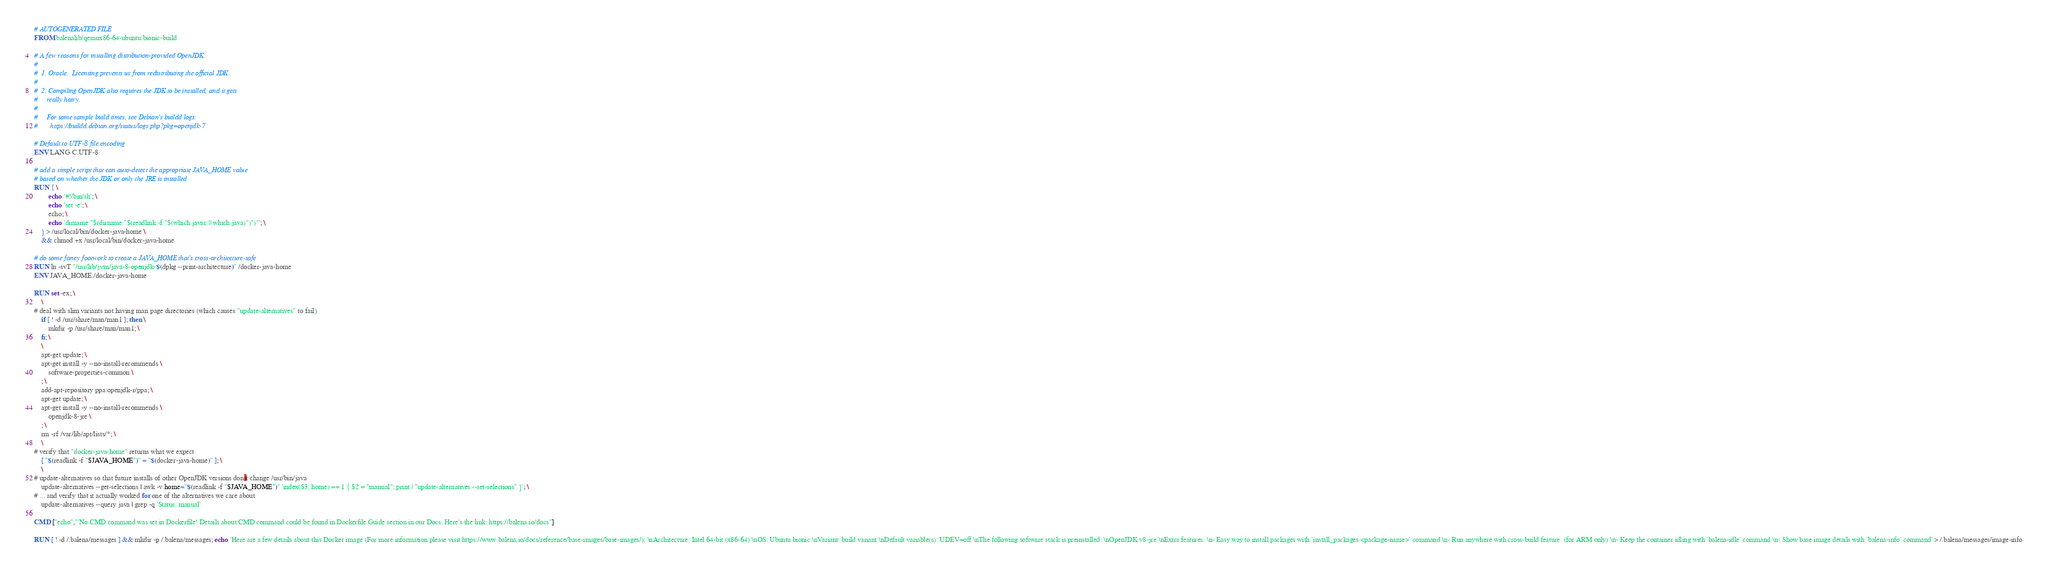Convert code to text. <code><loc_0><loc_0><loc_500><loc_500><_Dockerfile_># AUTOGENERATED FILE
FROM balenalib/qemux86-64-ubuntu:bionic-build

# A few reasons for installing distribution-provided OpenJDK:
#
#  1. Oracle.  Licensing prevents us from redistributing the official JDK.
#
#  2. Compiling OpenJDK also requires the JDK to be installed, and it gets
#     really hairy.
#
#     For some sample build times, see Debian's buildd logs:
#       https://buildd.debian.org/status/logs.php?pkg=openjdk-7

# Default to UTF-8 file.encoding
ENV LANG C.UTF-8

# add a simple script that can auto-detect the appropriate JAVA_HOME value
# based on whether the JDK or only the JRE is installed
RUN { \
		echo '#!/bin/sh'; \
		echo 'set -e'; \
		echo; \
		echo 'dirname "$(dirname "$(readlink -f "$(which javac || which java)")")"'; \
	} > /usr/local/bin/docker-java-home \
	&& chmod +x /usr/local/bin/docker-java-home

# do some fancy footwork to create a JAVA_HOME that's cross-architecture-safe
RUN ln -svT "/usr/lib/jvm/java-8-openjdk-$(dpkg --print-architecture)" /docker-java-home
ENV JAVA_HOME /docker-java-home

RUN set -ex; \
	\
# deal with slim variants not having man page directories (which causes "update-alternatives" to fail)
	if [ ! -d /usr/share/man/man1 ]; then \
		mkdir -p /usr/share/man/man1; \
	fi; \
	\
	apt-get update; \
	apt-get install -y --no-install-recommends \
		software-properties-common \
	; \
	add-apt-repository ppa:openjdk-r/ppa; \
	apt-get update; \
	apt-get install -y --no-install-recommends \
		openjdk-8-jre \
	; \
	rm -rf /var/lib/apt/lists/*; \
	\
# verify that "docker-java-home" returns what we expect
	[ "$(readlink -f "$JAVA_HOME")" = "$(docker-java-home)" ]; \
	\
# update-alternatives so that future installs of other OpenJDK versions don't change /usr/bin/java
	update-alternatives --get-selections | awk -v home="$(readlink -f "$JAVA_HOME")" 'index($3, home) == 1 { $2 = "manual"; print | "update-alternatives --set-selections" }'; \
# ... and verify that it actually worked for one of the alternatives we care about
	update-alternatives --query java | grep -q 'Status: manual'

CMD ["echo","'No CMD command was set in Dockerfile! Details about CMD command could be found in Dockerfile Guide section in our Docs. Here's the link: https://balena.io/docs"]

RUN [ ! -d /.balena/messages ] && mkdir -p /.balena/messages; echo 'Here are a few details about this Docker image (For more information please visit https://www.balena.io/docs/reference/base-images/base-images/): \nArchitecture: Intel 64-bit (x86-64) \nOS: Ubuntu bionic \nVariant: build variant \nDefault variable(s): UDEV=off \nThe following software stack is preinstalled: \nOpenJDK v8-jre \nExtra features: \n- Easy way to install packages with `install_packages <package-name>` command \n- Run anywhere with cross-build feature  (for ARM only) \n- Keep the container idling with `balena-idle` command \n- Show base image details with `balena-info` command' > /.balena/messages/image-info</code> 